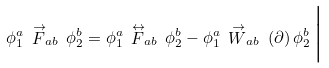<formula> <loc_0><loc_0><loc_500><loc_500>\phi ^ { a } _ { 1 } \, \stackrel { \rightarrow } { F } _ { a b } \, \phi ^ { b } _ { 2 } = \phi ^ { a } _ { 1 } \, \stackrel { \leftrightarrow } { F } _ { a b } \, \phi ^ { b } _ { 2 } - \phi ^ { a } _ { 1 } \, \stackrel { \rightarrow } { W } _ { a b } \, ( \partial ) \, \phi ^ { b } _ { 2 } \, \Big |</formula> 